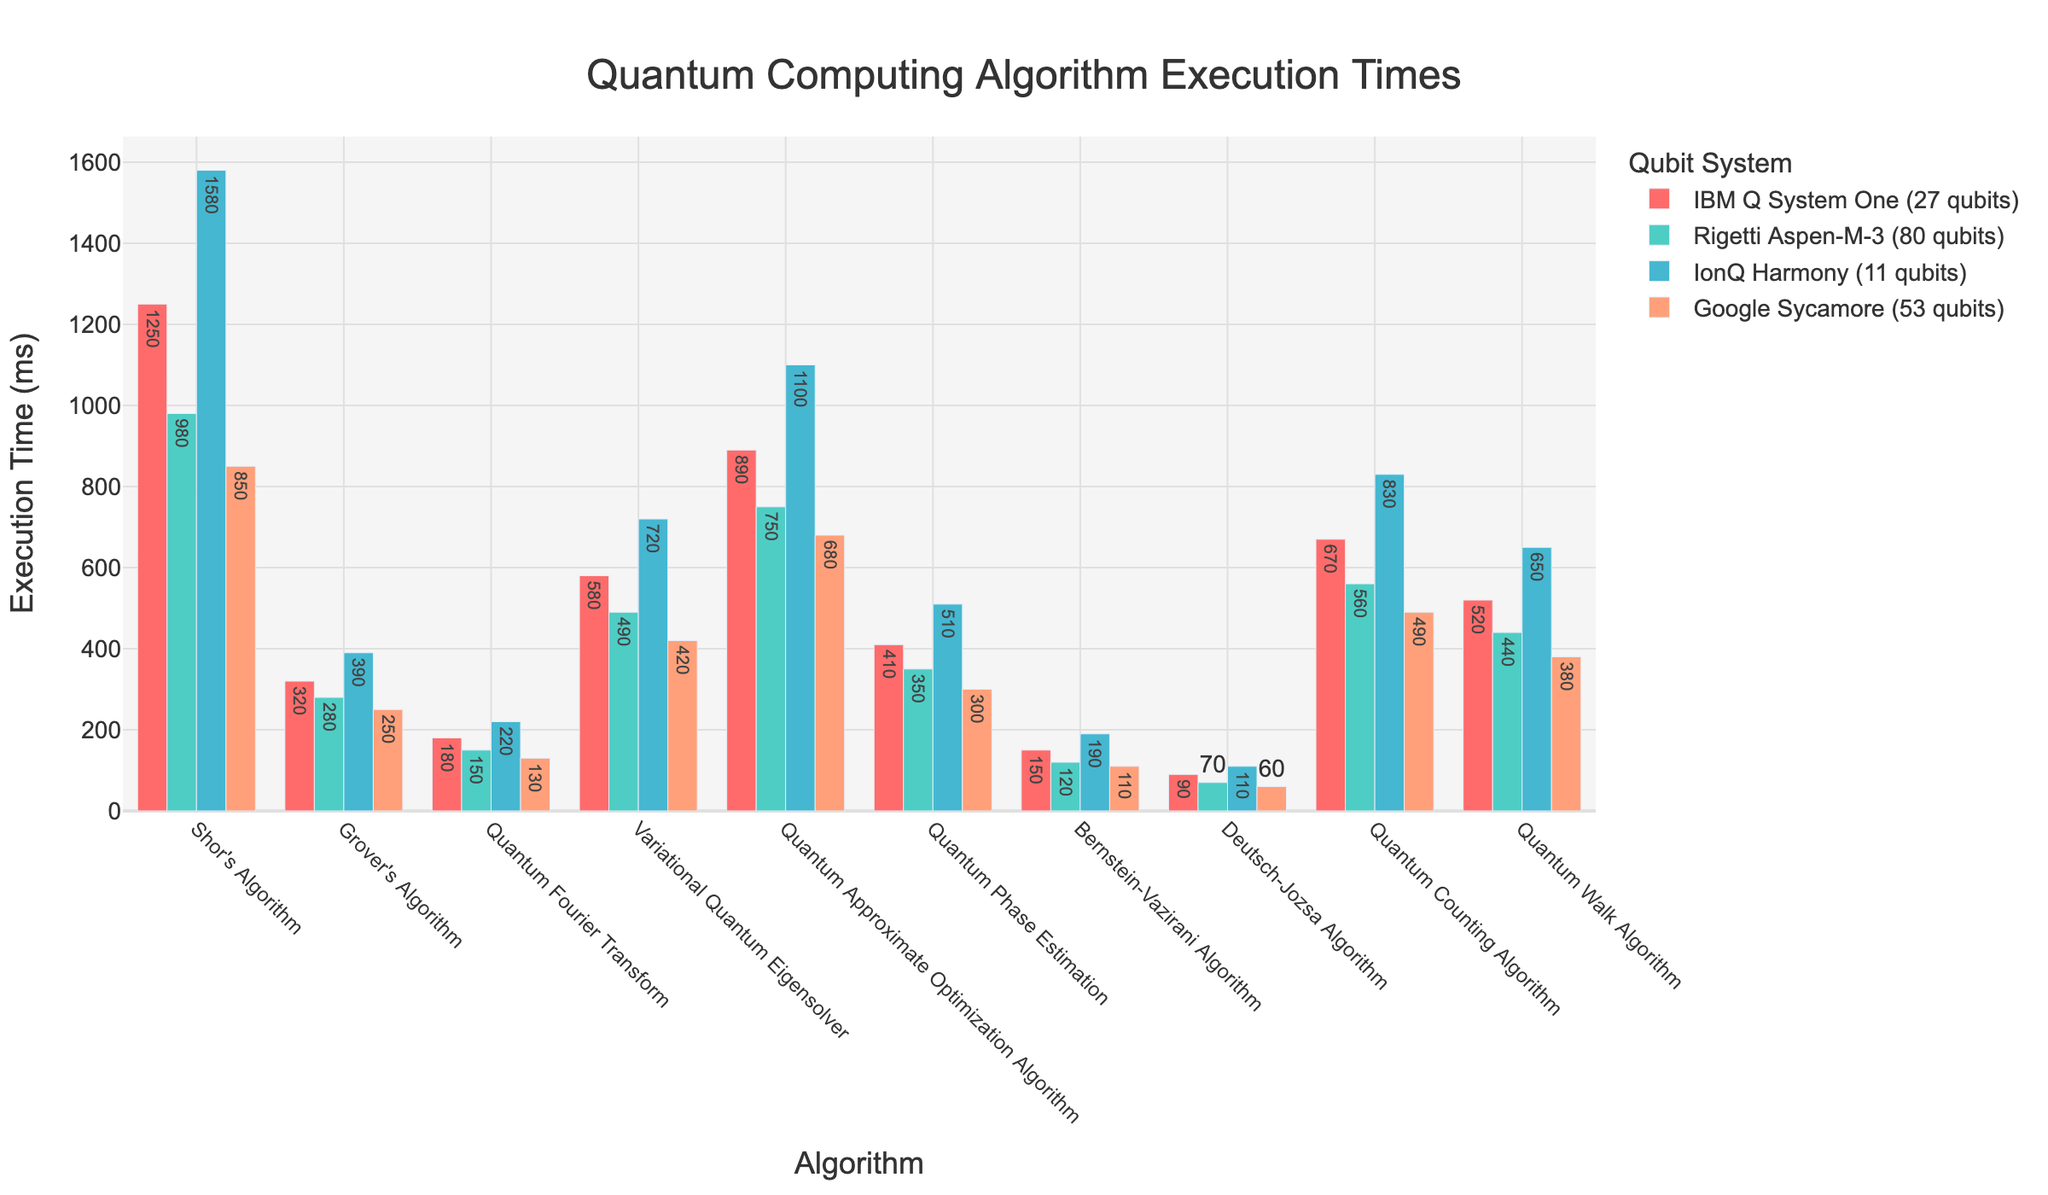Which algorithm has the longest execution time on IonQ Harmony (11 qubits)? Observe the data points for IonQ Harmony on the plot. The bar representing Shor's Algorithm is the highest, indicating the longest execution time.
Answer: Shor's Algorithm What is the average execution time for Quantum Fourier Transform across all qubit systems? Add the execution times for Quantum Fourier Transform on all systems: (180 + 150 + 220 + 130). Divide the sum by the number of systems, which is 4. The calculation is (180 + 150 + 220 + 130) / 4 = 680 / 4 = 170.
Answer: 170 ms Which algorithm shows the greatest difference in execution time between IBM Q System One (27 qubits) and Google Sycamore (53 qubits)? Calculate the absolute difference in execution times for each algorithm between IBM Q System One and Google Sycamore. The differences are: Shor's Algorithm: 400, Grover's Algorithm: 70, Quantum Fourier Transform: 50, Variational Quantum Eigensolver: 160, Quantum Approximate Optimization Algorithm: 210, Quantum Phase Estimation: 110, Bernstein-Vazirani Algorithm: 40, Deutsch-Jozsa Algorithm: 30, Quantum Counting Algorithm: 180, Quantum Walk Algorithm: 140. The greatest difference is for Shor's Algorithm at 400 ms.
Answer: Shor's Algorithm For the Bernstein-Vazirani Algorithm, which system has the lowest execution time? Observe the bars for Bernstein-Vazirani Algorithm. The shortest bar corresponds to Google Sycamore.
Answer: Google Sycamore How much faster is the execution time of Grover's Algorithm on Rigetti Aspen-M-3 (80 qubits) compared to IonQ Harmony (11 qubits)? Subtract the execution time of Grover's Algorithm on Rigetti Aspen-M-3 (280 ms) from IonQ Harmony (390 ms). The calculation is 390 - 280 = 110 ms.
Answer: 110 ms What is the combined execution time of Quantum Phase Estimation on IBM Q System One (27 qubits) and Rigetti Aspen-M-3 (80 qubits)? Add the execution times from IBM Q System One and Rigetti Aspen-M-3 for Quantum Phase Estimation. The sum is 410 + 350 = 760 ms.
Answer: 760 ms Which qubit system generally has the lowest execution times across all algorithms? Compare the heights of bars for all algorithms across all systems. Google Sycamore has the lowest execution times in most cases, indicated by the shortest bars.
Answer: Google Sycamore What is the relative difference in execution time between the Quantum Approximate Optimization Algorithm and the Quantum Fourier Transform on IonQ Harmony (11 qubits)? Subtract the execution time of Quantum Fourier Transform (220 ms) from Quantum Approximate Optimization Algorithm (1100 ms). The difference is 1100 - 220 = 880 ms.
Answer: 880 ms Identify the algorithm with the smallest execution time difference between IBM Q System One (27 qubits) and Rigetti Aspen-M-3 (80 qubits). Calculate the absolute difference for each algorithm between IBM Q System One and Rigetti Aspen-M-3. The differences are: Shor's Algorithm: 270, Grover's Algorithm: 40, Quantum Fourier Transform: 30, Variational Quantum Eigensolver: 90, Quantum Approximate Optimization Algorithm: 140, Quantum Phase Estimation: 60, Bernstein-Vazirani Algorithm: 30, Deutsch-Jozsa Algorithm: 20, Quantum Counting Algorithm: 110, Quantum Walk Algorithm: 80. The smallest difference is for Deutsch-Jozsa Algorithm at 20 ms.
Answer: Deutsch-Jozsa Algorithm 